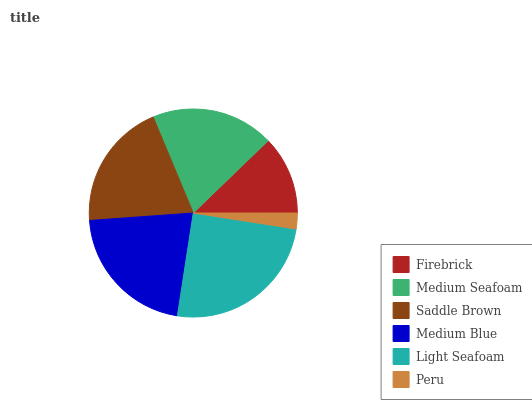Is Peru the minimum?
Answer yes or no. Yes. Is Light Seafoam the maximum?
Answer yes or no. Yes. Is Medium Seafoam the minimum?
Answer yes or no. No. Is Medium Seafoam the maximum?
Answer yes or no. No. Is Medium Seafoam greater than Firebrick?
Answer yes or no. Yes. Is Firebrick less than Medium Seafoam?
Answer yes or no. Yes. Is Firebrick greater than Medium Seafoam?
Answer yes or no. No. Is Medium Seafoam less than Firebrick?
Answer yes or no. No. Is Saddle Brown the high median?
Answer yes or no. Yes. Is Medium Seafoam the low median?
Answer yes or no. Yes. Is Medium Blue the high median?
Answer yes or no. No. Is Saddle Brown the low median?
Answer yes or no. No. 